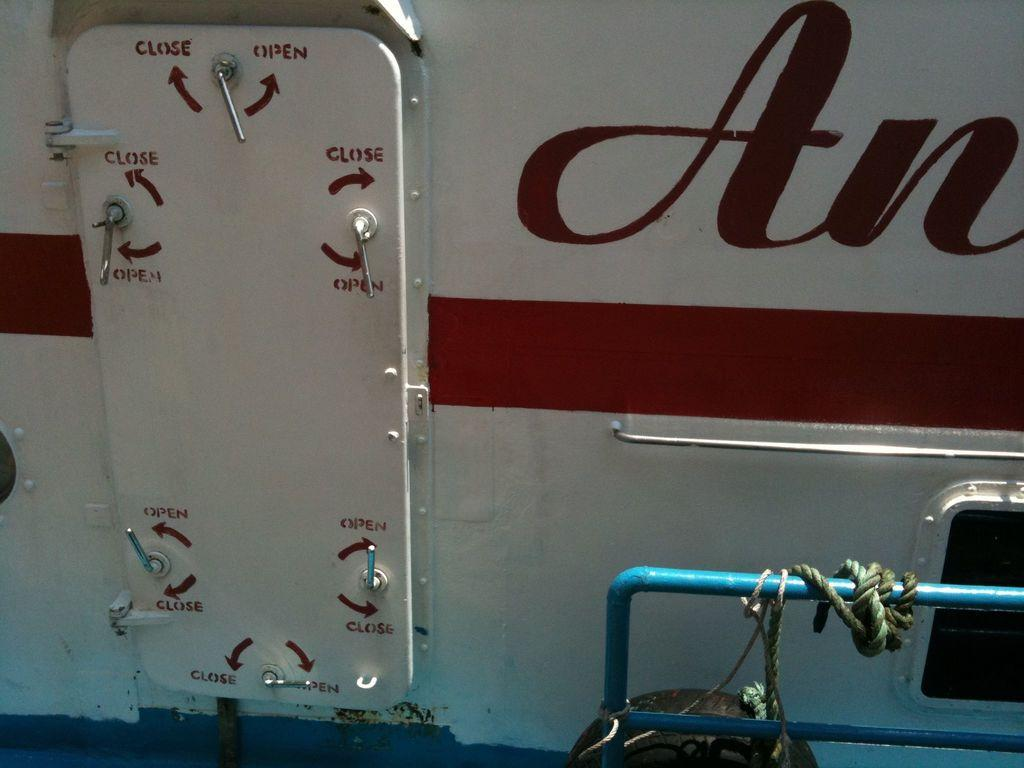What can be seen on the right side of the image? There is a fencing in the bottom right side of the image. What is attached to the fencing? There is a rope on the fencing. What is located behind the fencing? There is a vehicle behind the fencing. What type of dirt can be seen on the ground near the fencing? There is no dirt visible near the fencing in the image. What kind of structure is the fencing supporting in the image? The image does not show the fencing supporting any structure. 